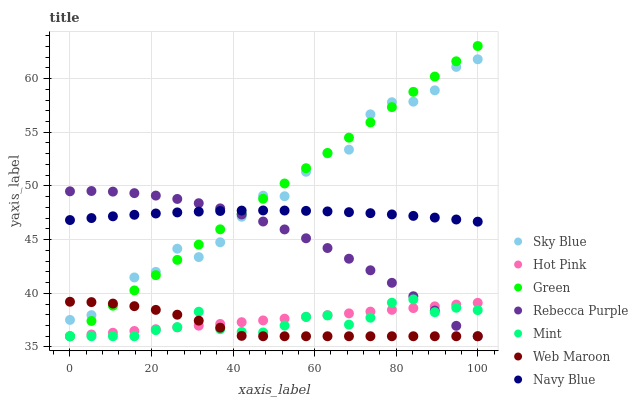Does Web Maroon have the minimum area under the curve?
Answer yes or no. Yes. Does Green have the maximum area under the curve?
Answer yes or no. Yes. Does Hot Pink have the minimum area under the curve?
Answer yes or no. No. Does Hot Pink have the maximum area under the curve?
Answer yes or no. No. Is Green the smoothest?
Answer yes or no. Yes. Is Sky Blue the roughest?
Answer yes or no. Yes. Is Hot Pink the smoothest?
Answer yes or no. No. Is Hot Pink the roughest?
Answer yes or no. No. Does Hot Pink have the lowest value?
Answer yes or no. Yes. Does Sky Blue have the lowest value?
Answer yes or no. No. Does Green have the highest value?
Answer yes or no. Yes. Does Web Maroon have the highest value?
Answer yes or no. No. Is Hot Pink less than Sky Blue?
Answer yes or no. Yes. Is Sky Blue greater than Mint?
Answer yes or no. Yes. Does Rebecca Purple intersect Hot Pink?
Answer yes or no. Yes. Is Rebecca Purple less than Hot Pink?
Answer yes or no. No. Is Rebecca Purple greater than Hot Pink?
Answer yes or no. No. Does Hot Pink intersect Sky Blue?
Answer yes or no. No. 